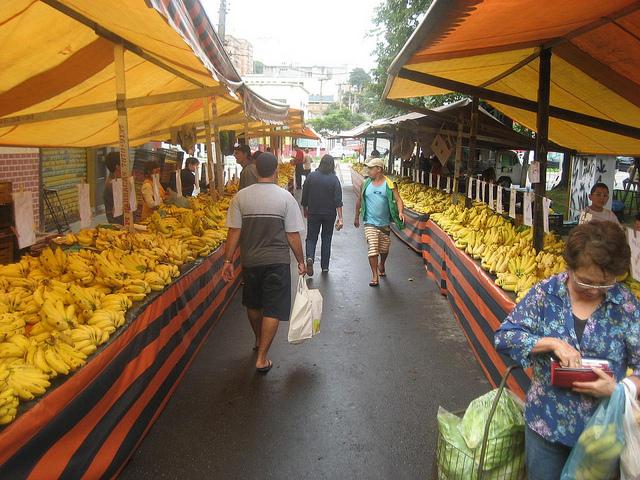Is the woman right front wearing glasses?
Concise answer only. Yes. What is being sold?
Answer briefly. Bananas. Has anyone purchased anything in this photo?
Concise answer only. Yes. 